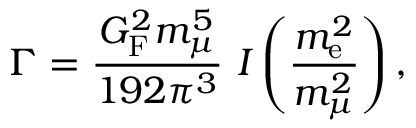<formula> <loc_0><loc_0><loc_500><loc_500>\Gamma = { \frac { G _ { F } ^ { 2 } m _ { \mu } ^ { 5 } } { 1 9 2 \pi ^ { 3 } } } I \left ( { \frac { m _ { e } ^ { 2 } } { m _ { \mu } ^ { 2 } } } \right ) ,</formula> 